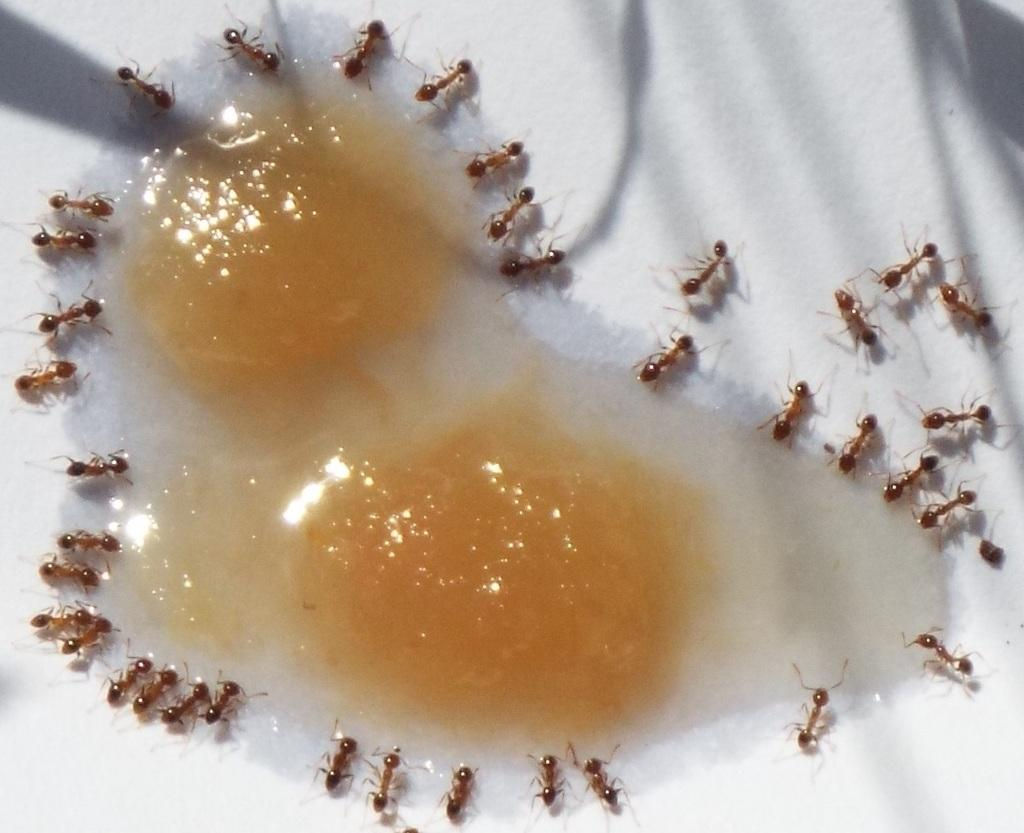What is depicted in the image? There is food and ants in the image. What is the color of the surface where the food and ants are present? The surface is white. How much blood can be seen on the ants in the image? There is no blood present in the image; it features food and ants on a white surface. What type of control system is being used by the ants in the image? There is no control system present in the image; it features food and ants on a white surface. 